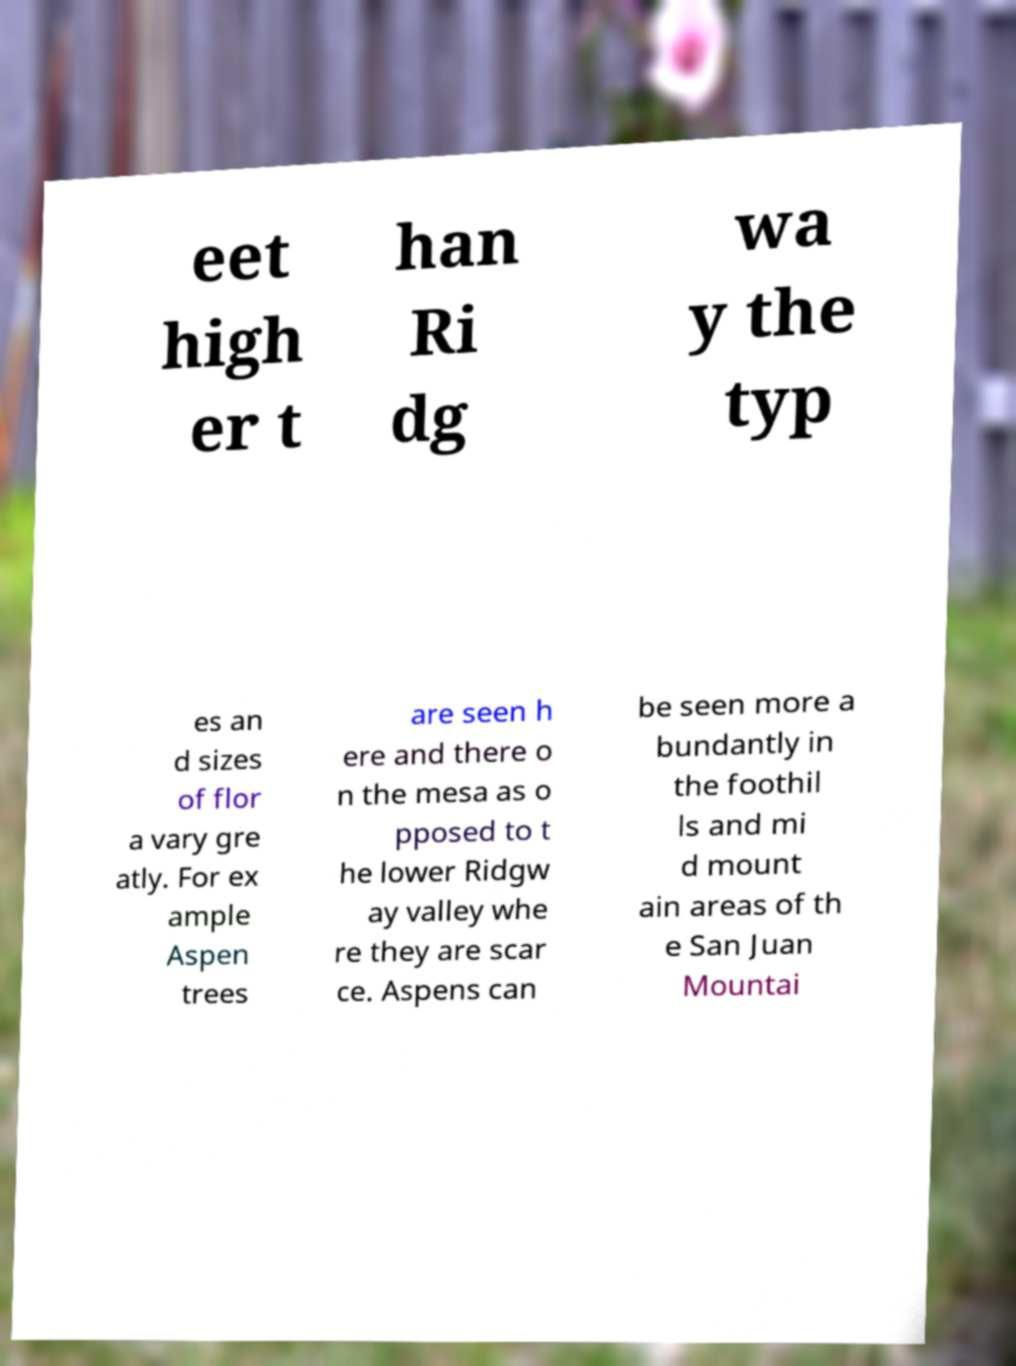I need the written content from this picture converted into text. Can you do that? eet high er t han Ri dg wa y the typ es an d sizes of flor a vary gre atly. For ex ample Aspen trees are seen h ere and there o n the mesa as o pposed to t he lower Ridgw ay valley whe re they are scar ce. Aspens can be seen more a bundantly in the foothil ls and mi d mount ain areas of th e San Juan Mountai 